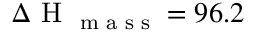<formula> <loc_0><loc_0><loc_500><loc_500>\Delta H _ { m a s s } = 9 6 . 2</formula> 